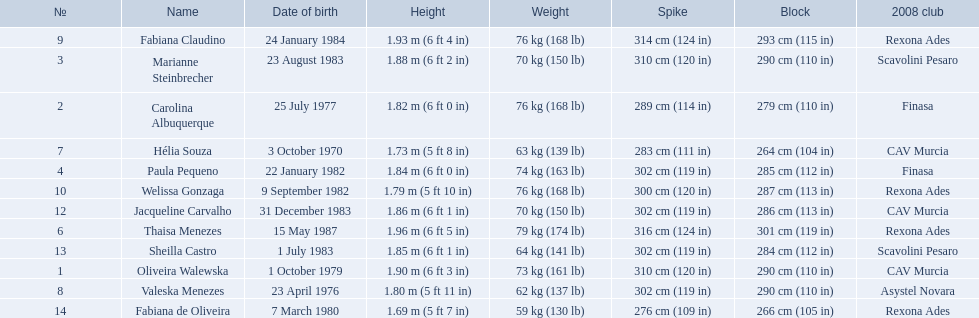Who are the players for brazil at the 2008 summer olympics? Oliveira Walewska, Carolina Albuquerque, Marianne Steinbrecher, Paula Pequeno, Thaisa Menezes, Hélia Souza, Valeska Menezes, Fabiana Claudino, Welissa Gonzaga, Jacqueline Carvalho, Sheilla Castro, Fabiana de Oliveira. What are their heights? 1.90 m (6 ft 3 in), 1.82 m (6 ft 0 in), 1.88 m (6 ft 2 in), 1.84 m (6 ft 0 in), 1.96 m (6 ft 5 in), 1.73 m (5 ft 8 in), 1.80 m (5 ft 11 in), 1.93 m (6 ft 4 in), 1.79 m (5 ft 10 in), 1.86 m (6 ft 1 in), 1.85 m (6 ft 1 in), 1.69 m (5 ft 7 in). What is the shortest height? 1.69 m (5 ft 7 in). Which player is that? Fabiana de Oliveira. 